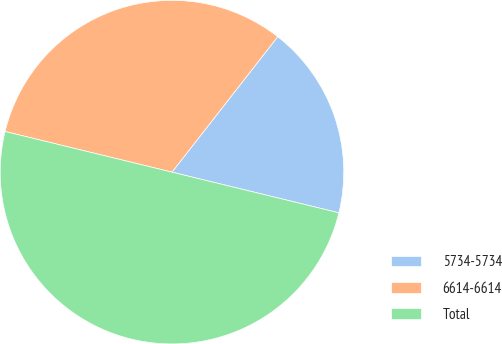<chart> <loc_0><loc_0><loc_500><loc_500><pie_chart><fcel>5734-5734<fcel>6614-6614<fcel>Total<nl><fcel>18.25%<fcel>31.75%<fcel>50.0%<nl></chart> 